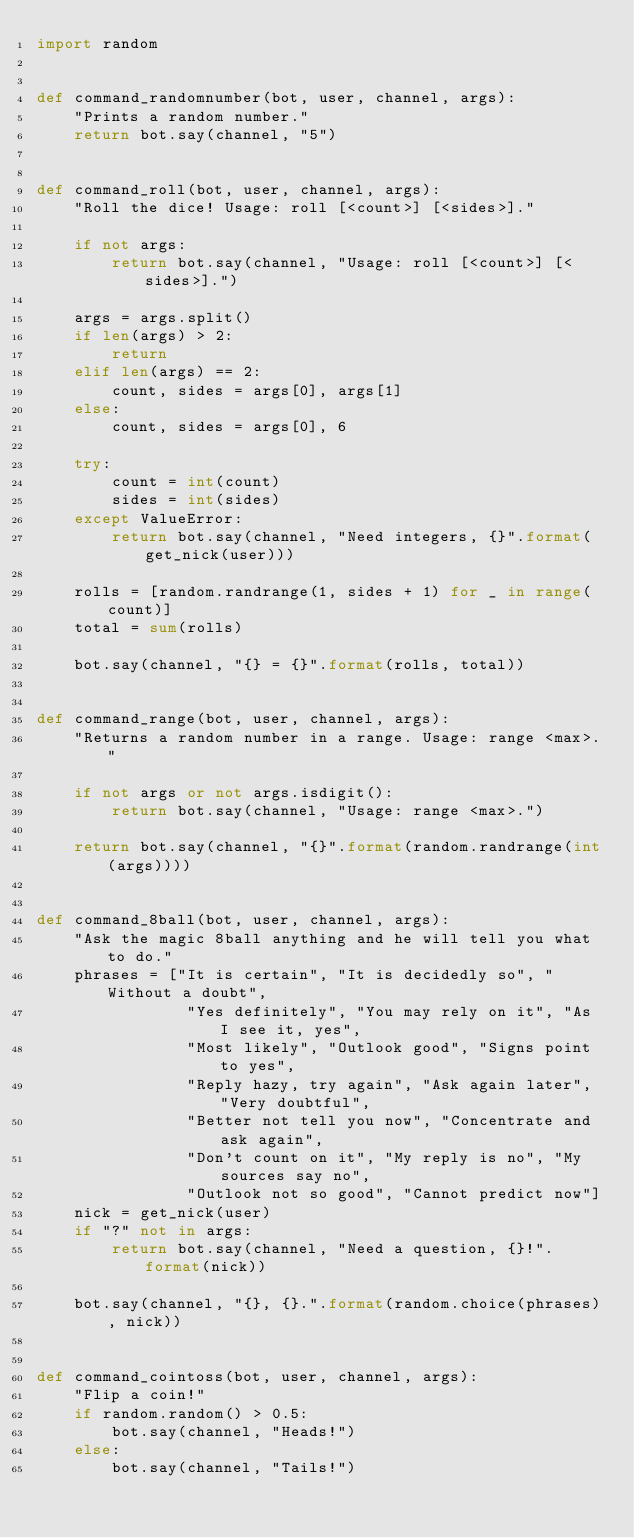Convert code to text. <code><loc_0><loc_0><loc_500><loc_500><_Python_>import random


def command_randomnumber(bot, user, channel, args):
    "Prints a random number."
    return bot.say(channel, "5")


def command_roll(bot, user, channel, args):
    "Roll the dice! Usage: roll [<count>] [<sides>]."

    if not args:
        return bot.say(channel, "Usage: roll [<count>] [<sides>].")

    args = args.split()
    if len(args) > 2:
        return
    elif len(args) == 2:
        count, sides = args[0], args[1]
    else:
        count, sides = args[0], 6

    try:
        count = int(count)
        sides = int(sides)
    except ValueError:
        return bot.say(channel, "Need integers, {}".format(get_nick(user)))

    rolls = [random.randrange(1, sides + 1) for _ in range(count)]
    total = sum(rolls)

    bot.say(channel, "{} = {}".format(rolls, total))


def command_range(bot, user, channel, args):
    "Returns a random number in a range. Usage: range <max>."

    if not args or not args.isdigit():
        return bot.say(channel, "Usage: range <max>.")

    return bot.say(channel, "{}".format(random.randrange(int(args))))


def command_8ball(bot, user, channel, args):
    "Ask the magic 8ball anything and he will tell you what to do."
    phrases = ["It is certain", "It is decidedly so", "Without a doubt",
                "Yes definitely", "You may rely on it", "As I see it, yes",
                "Most likely", "Outlook good", "Signs point to yes",
                "Reply hazy, try again", "Ask again later", "Very doubtful",
                "Better not tell you now", "Concentrate and ask again",
                "Don't count on it", "My reply is no", "My sources say no",
                "Outlook not so good", "Cannot predict now"]
    nick = get_nick(user)
    if "?" not in args:
        return bot.say(channel, "Need a question, {}!".format(nick))

    bot.say(channel, "{}, {}.".format(random.choice(phrases), nick))


def command_cointoss(bot, user, channel, args):
    "Flip a coin!"
    if random.random() > 0.5:
        bot.say(channel, "Heads!")
    else:
        bot.say(channel, "Tails!")
</code> 